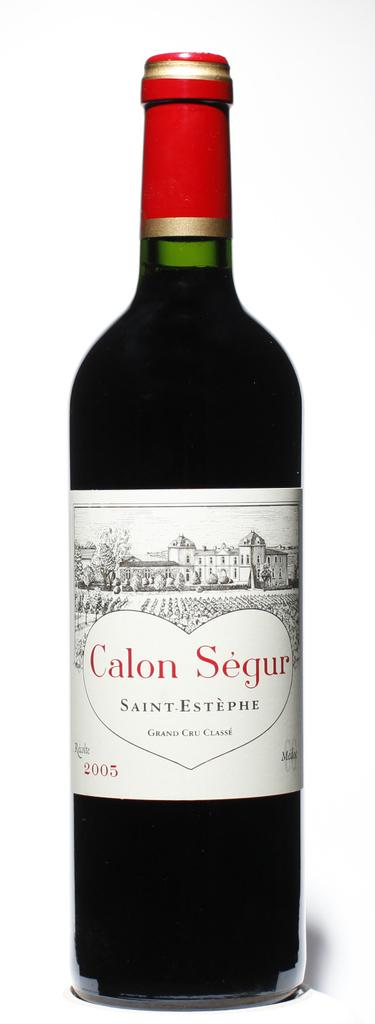What year is this wine from?
Ensure brevity in your answer.  2005. 